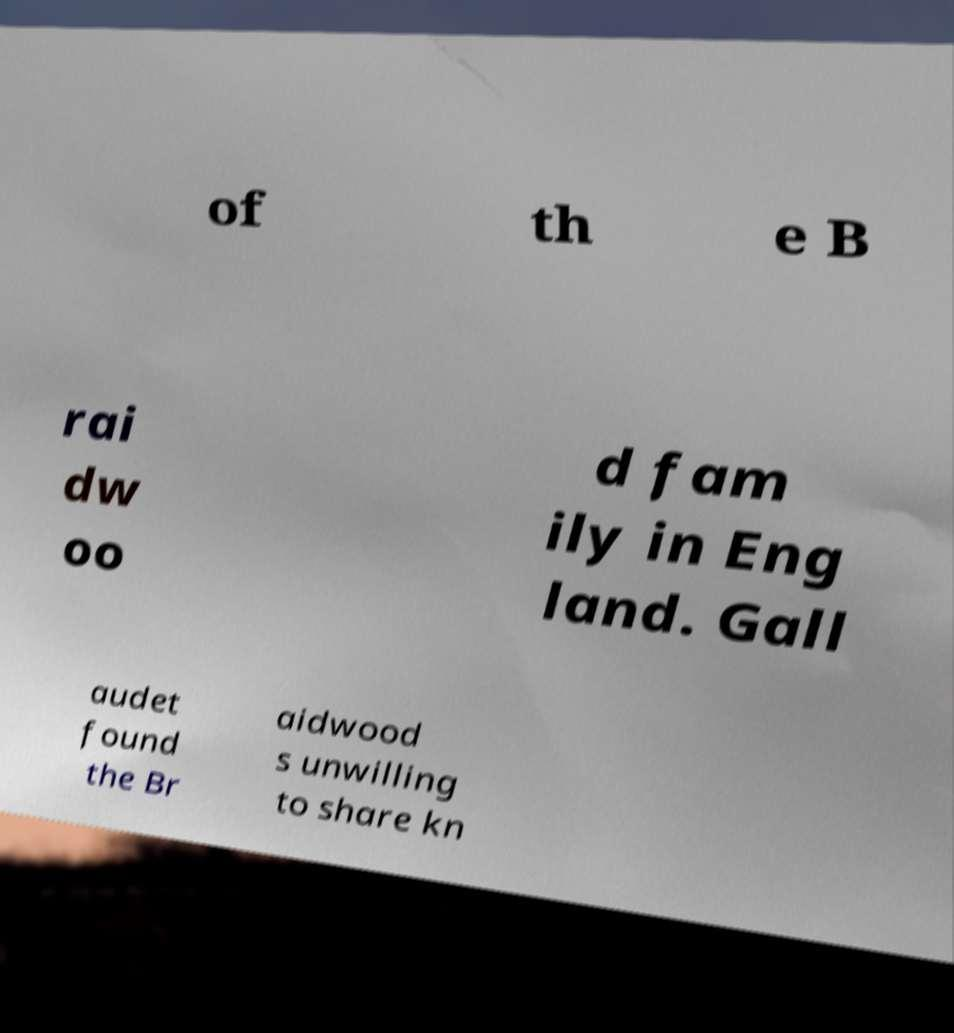For documentation purposes, I need the text within this image transcribed. Could you provide that? of th e B rai dw oo d fam ily in Eng land. Gall audet found the Br aidwood s unwilling to share kn 